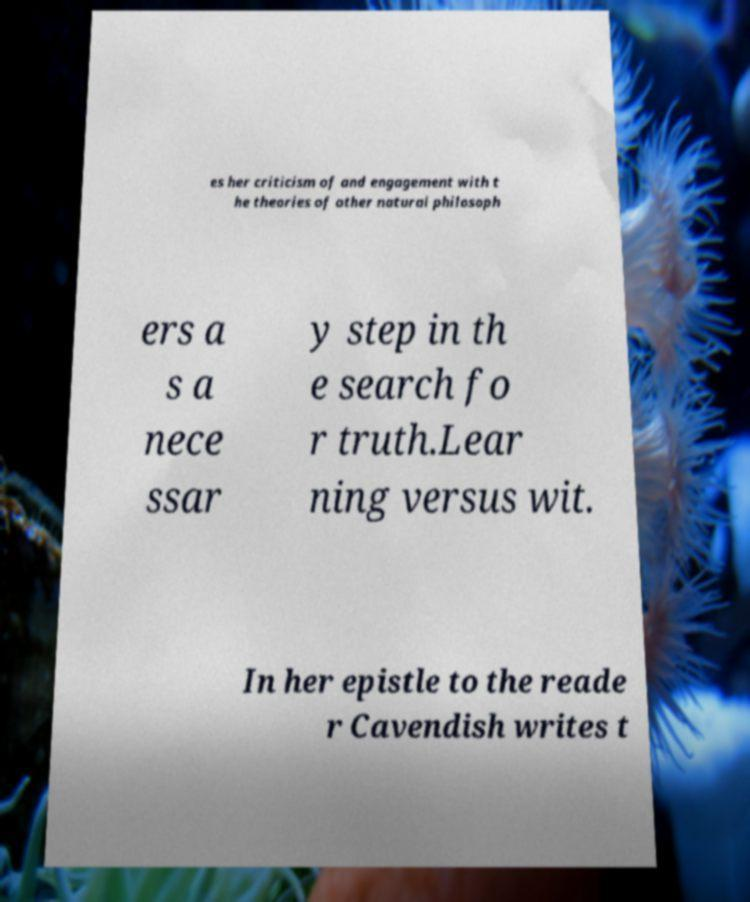Can you read and provide the text displayed in the image?This photo seems to have some interesting text. Can you extract and type it out for me? es her criticism of and engagement with t he theories of other natural philosoph ers a s a nece ssar y step in th e search fo r truth.Lear ning versus wit. In her epistle to the reade r Cavendish writes t 